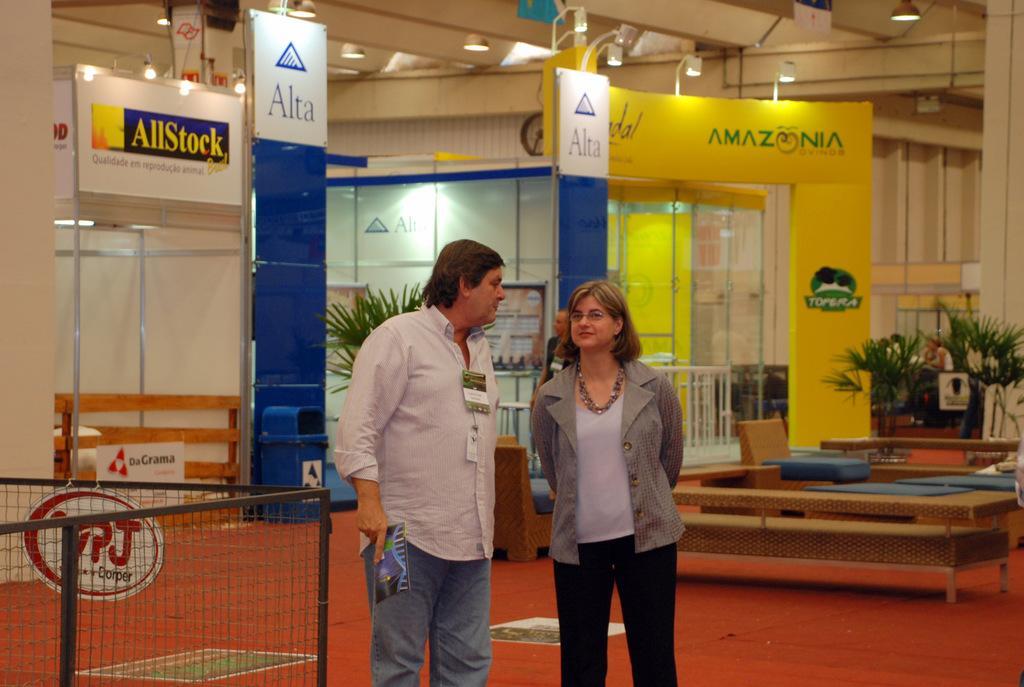Can you describe this image briefly? In this image there are two persons standing. At the back there are plants, at the top there are lights, there are hoardings at the back, at the left there is a dustbin. 